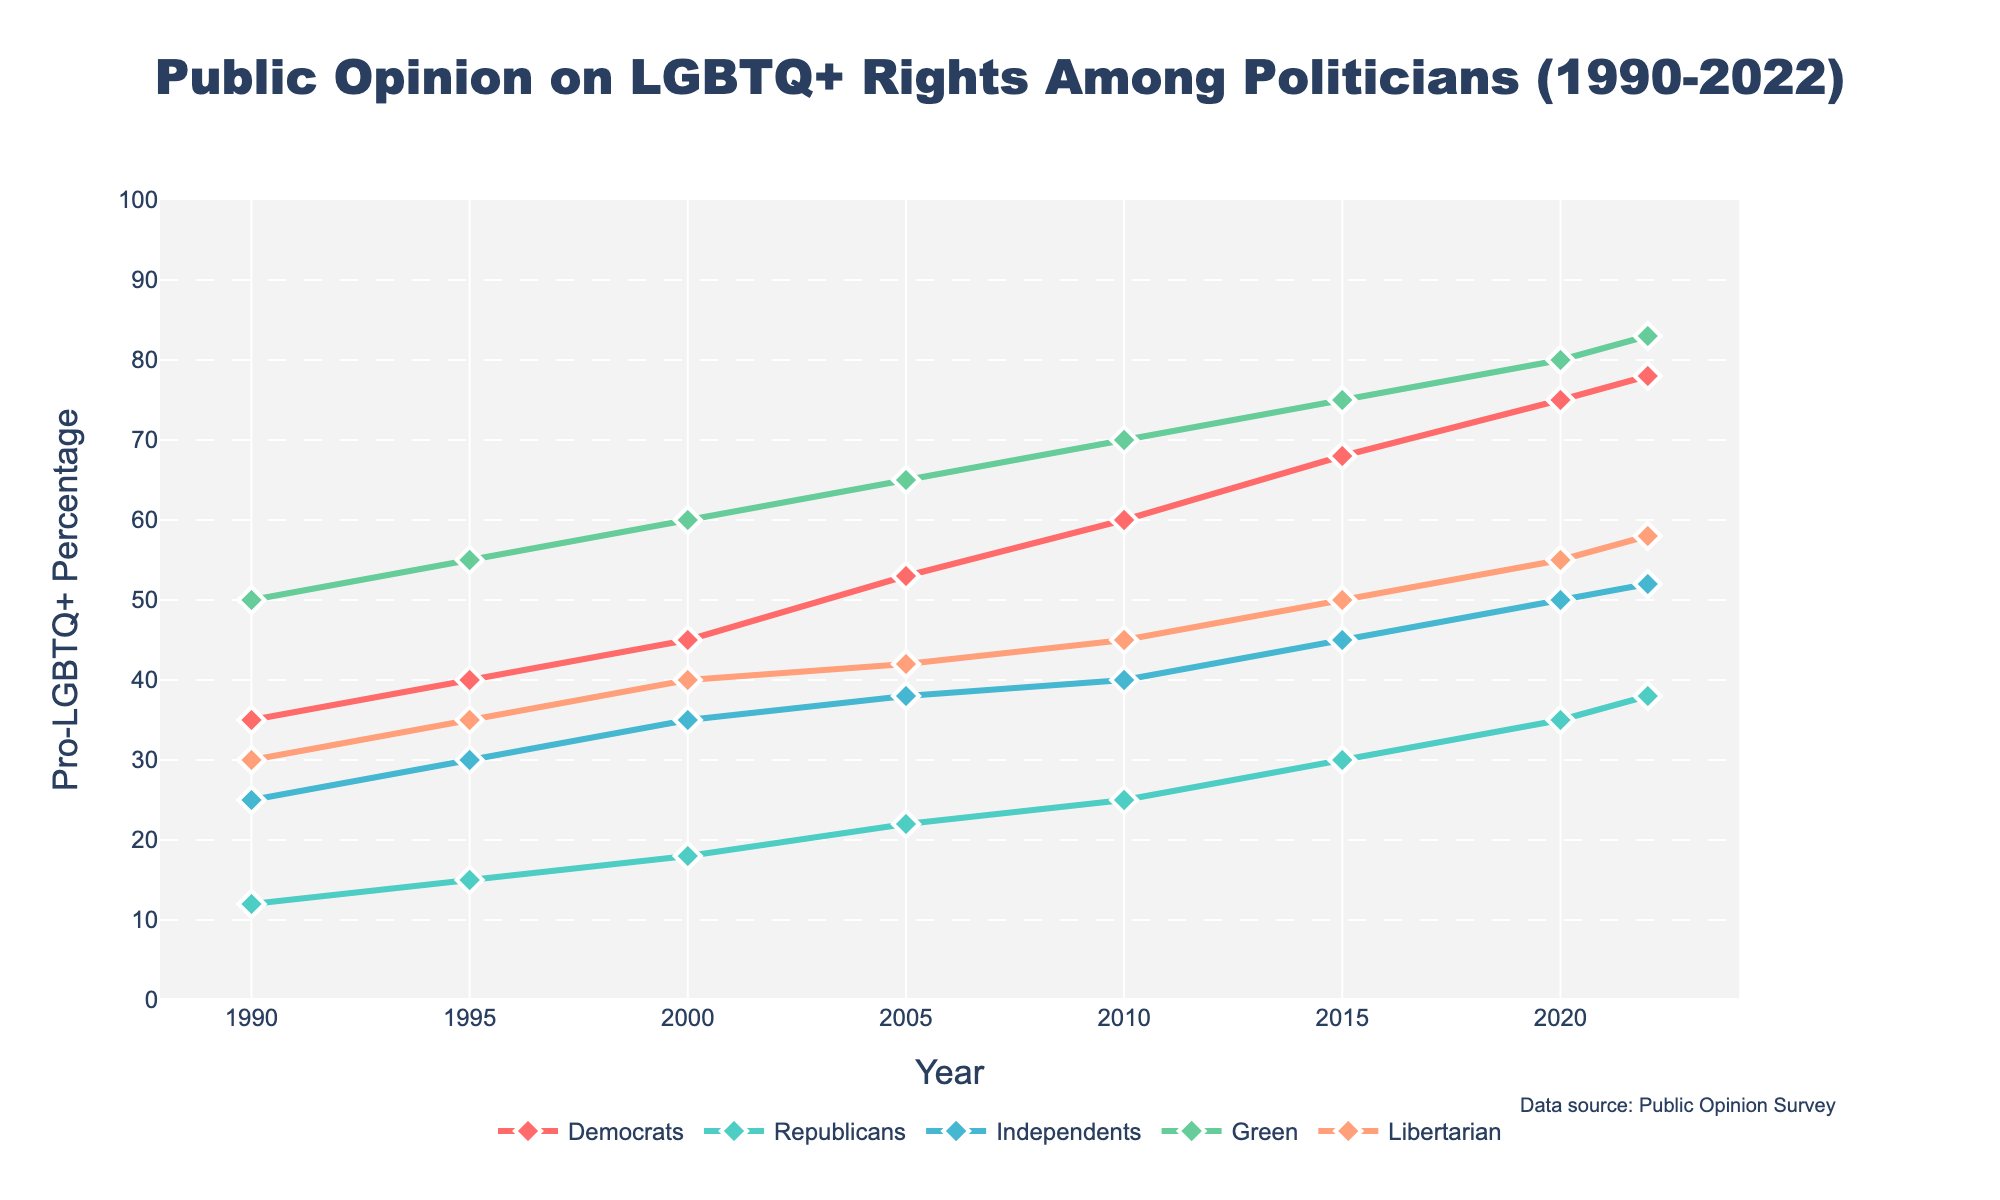What is the title of the figure? The title is located at the top of the plot in a larger font size and it reads 'Public Opinion on LGBTQ+ Rights Among Politicians (1990-2022)'.
Answer: Public Opinion on LGBTQ+ Rights Among Politicians (1990-2022) In which year did the Democratic Party's support for LGBTQ+ rights surpass 50%? The data points for the Democratic Party are marked with points for each year. The first year the value is above 50% is at 2005.
Answer: 2005 Which party shows the most significant increase in pro-LGBTQ+ percentage from 1990 to 2022? Calculate the difference between the 2022 and 1990 percentages for each party: Democrats (78-35), Republicans (38-12), Independents (52-25), Green Party (83-50), Libertarian Party (58-30). The largest difference is from the Green Party, with an increase of 33 percentage points.
Answer: Green Party What can be said about the trend of Republican support for LGBTQ+ rights over the years? Observing the line for the Republican Party from 1990 to 2022, the line generally shows an upward trend, slowly increasing from 12% to 38% over the years.
Answer: Increasing trend Compare the pro-LGBTQ+ percentages of Democrats and Libertarians in 2020. Which party had higher support and by how much? In 2020, the Democrats had a support percentage of 75%, while the Libertarians had 55%. Subtract the Libertarian percentage from the Democrat percentage: 75 - 55 = 20. The Democrats had 20% higher support.
Answer: Democrats by 20% What is the average pro-LGBTQ+ percentage for the Green Party and the Libertarian Party in 2000? Find the percentages for 2000 (Green Party: 60, Libertarian Party: 40) and calculate the average: (60 + 40) / 2 = 50.
Answer: 50% Between 2010 and 2022, which party had the least increase in pro-LGBTQ+ percentage? Calculate the difference between 2022 and 2010 for each party: Democrats (78-60), Republicans (38-25), Independents (52-40), Green Party (83-70), Libertarian Party (58-45). The smallest difference is for the Republicans, with an increase of 13.
Answer: Republicans What was the percentage difference in pro-LGBTQ+ support between Independents and Republicans in 1995? In 1995, Independents had 30% support and Republicans had 15%. Subtract the Republican percentage from the Independent percentage: 30 - 15 = 15.
Answer: 15% Describe the overall trend in pro-LGBTQ+ support among all presented political parties from 1990 to 2022. All parties show an increasing trend in pro-LGBTQ+ support over the years, although the rates of increase and the absolute percentages vary significantly among different parties. The Green Party and Democrats show the highest levels of support, while Republicans show the slowest growth.
Answer: Increasing for all parties 